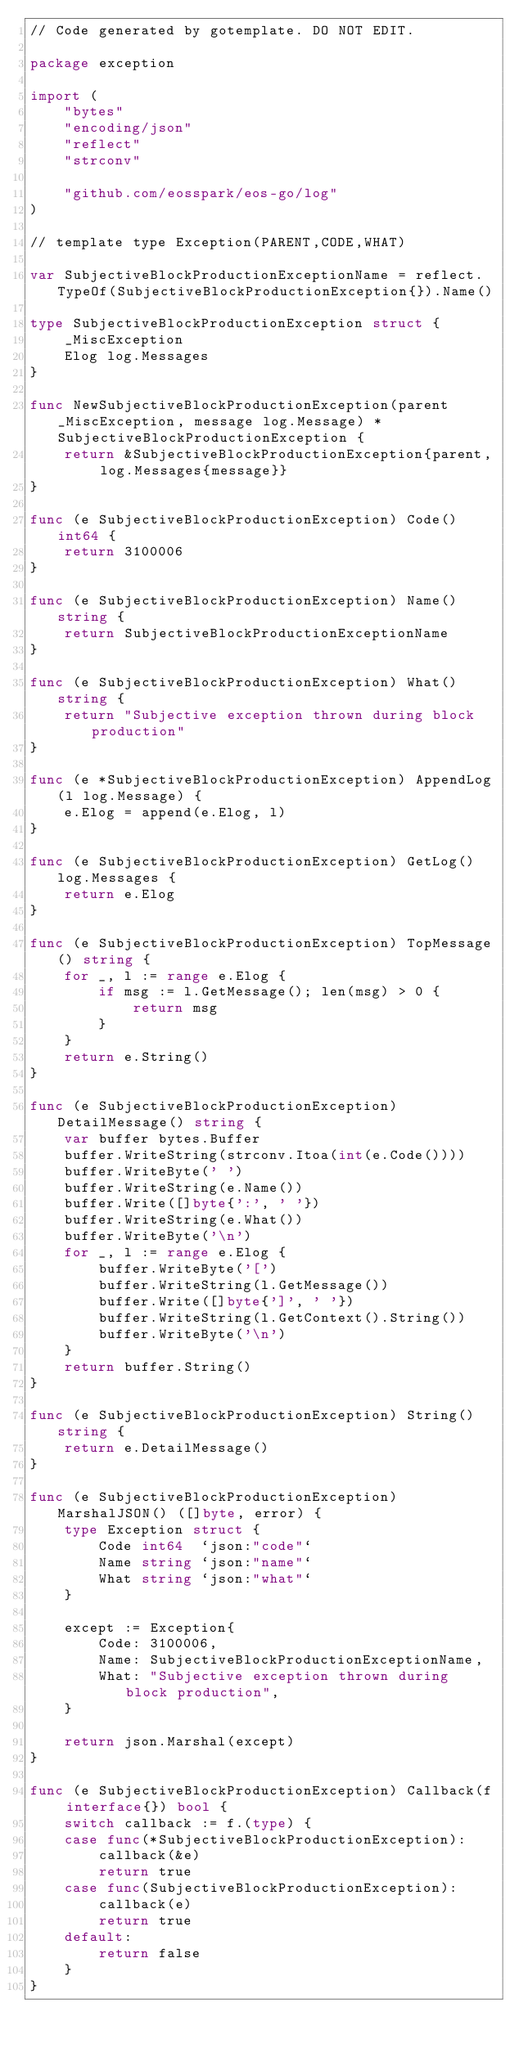Convert code to text. <code><loc_0><loc_0><loc_500><loc_500><_Go_>// Code generated by gotemplate. DO NOT EDIT.

package exception

import (
	"bytes"
	"encoding/json"
	"reflect"
	"strconv"

	"github.com/eosspark/eos-go/log"
)

// template type Exception(PARENT,CODE,WHAT)

var SubjectiveBlockProductionExceptionName = reflect.TypeOf(SubjectiveBlockProductionException{}).Name()

type SubjectiveBlockProductionException struct {
	_MiscException
	Elog log.Messages
}

func NewSubjectiveBlockProductionException(parent _MiscException, message log.Message) *SubjectiveBlockProductionException {
	return &SubjectiveBlockProductionException{parent, log.Messages{message}}
}

func (e SubjectiveBlockProductionException) Code() int64 {
	return 3100006
}

func (e SubjectiveBlockProductionException) Name() string {
	return SubjectiveBlockProductionExceptionName
}

func (e SubjectiveBlockProductionException) What() string {
	return "Subjective exception thrown during block production"
}

func (e *SubjectiveBlockProductionException) AppendLog(l log.Message) {
	e.Elog = append(e.Elog, l)
}

func (e SubjectiveBlockProductionException) GetLog() log.Messages {
	return e.Elog
}

func (e SubjectiveBlockProductionException) TopMessage() string {
	for _, l := range e.Elog {
		if msg := l.GetMessage(); len(msg) > 0 {
			return msg
		}
	}
	return e.String()
}

func (e SubjectiveBlockProductionException) DetailMessage() string {
	var buffer bytes.Buffer
	buffer.WriteString(strconv.Itoa(int(e.Code())))
	buffer.WriteByte(' ')
	buffer.WriteString(e.Name())
	buffer.Write([]byte{':', ' '})
	buffer.WriteString(e.What())
	buffer.WriteByte('\n')
	for _, l := range e.Elog {
		buffer.WriteByte('[')
		buffer.WriteString(l.GetMessage())
		buffer.Write([]byte{']', ' '})
		buffer.WriteString(l.GetContext().String())
		buffer.WriteByte('\n')
	}
	return buffer.String()
}

func (e SubjectiveBlockProductionException) String() string {
	return e.DetailMessage()
}

func (e SubjectiveBlockProductionException) MarshalJSON() ([]byte, error) {
	type Exception struct {
		Code int64  `json:"code"`
		Name string `json:"name"`
		What string `json:"what"`
	}

	except := Exception{
		Code: 3100006,
		Name: SubjectiveBlockProductionExceptionName,
		What: "Subjective exception thrown during block production",
	}

	return json.Marshal(except)
}

func (e SubjectiveBlockProductionException) Callback(f interface{}) bool {
	switch callback := f.(type) {
	case func(*SubjectiveBlockProductionException):
		callback(&e)
		return true
	case func(SubjectiveBlockProductionException):
		callback(e)
		return true
	default:
		return false
	}
}
</code> 